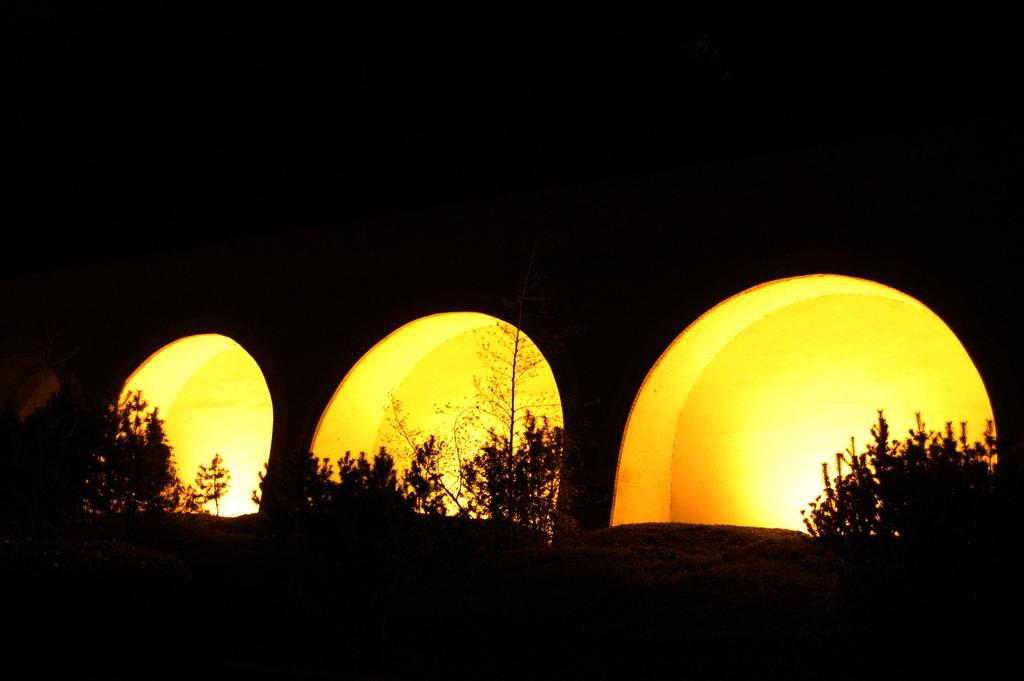What is attached to the wall in the image? There are lights on the wall in the image. What type of living organisms can be seen in the image? There are plants in the image. How would you describe the lighting conditions in the top part of the image? The top part of the image appears to be dark. Can you see any wings on the plants in the image? There are no wings visible on the plants in the image. What type of grain is being harvested by the queen in the image? There is no queen or grain present in the image. 